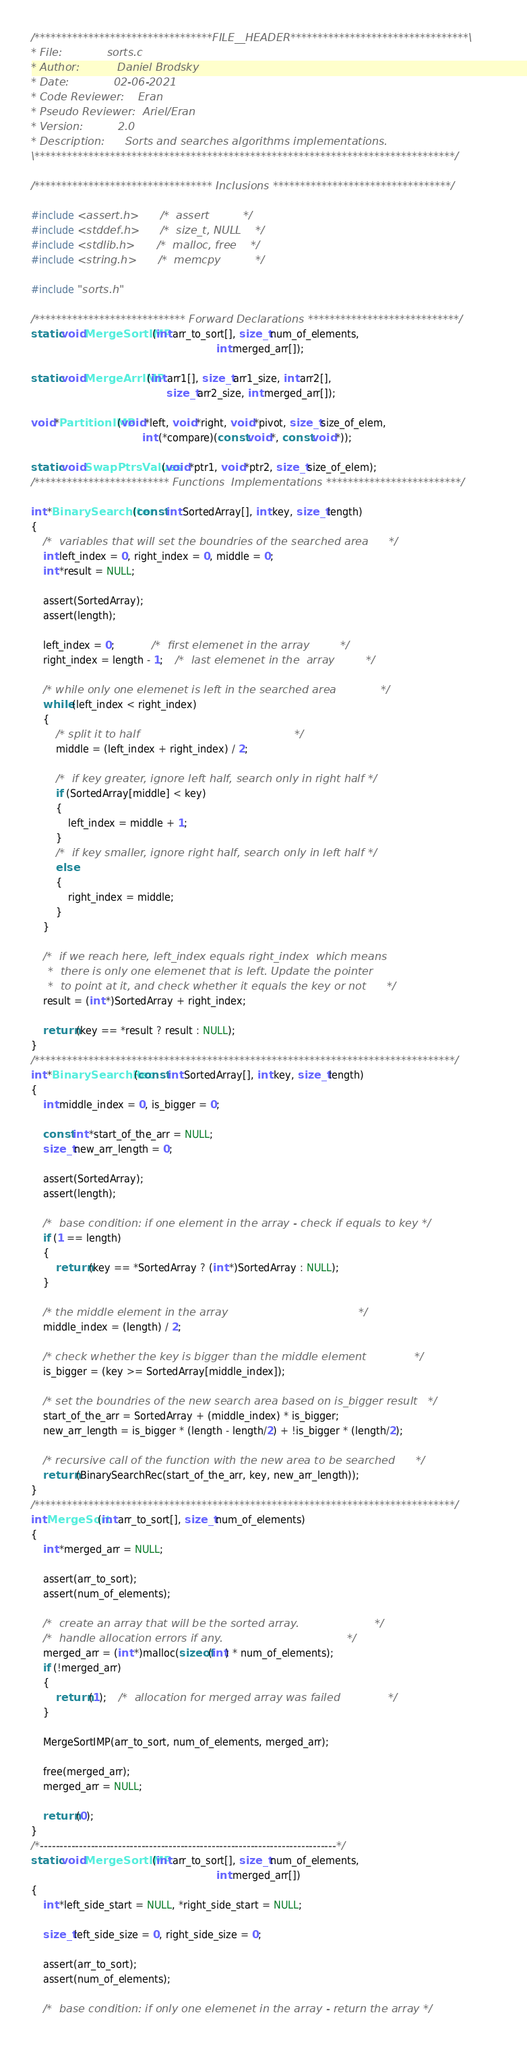Convert code to text. <code><loc_0><loc_0><loc_500><loc_500><_C_>/*********************************FILE__HEADER*********************************\
* File:				sorts.c
* Author:			Daniel Brodsky				 		  												  								
* Date:				02-06-2021
* Code Reviewer:	Eran
* Pseudo Reviewer: 	Ariel/Eran				   								
* Version:			2.0  								
* Description:		Sorts and searches algorithms implementations. 
\******************************************************************************/

/********************************* Inclusions *********************************/

#include <assert.h>		/*	assert			*/
#include <stddef.h>		/*	size_t, NULL	*/
#include <stdlib.h>		/*	malloc, free	*/
#include <string.h>		/*	memcpy			*/

#include "sorts.h"

/**************************** Forward Declarations ****************************/
static void MergeSortIMP(int arr_to_sort[], size_t num_of_elements,
															int merged_arr[]);

static void MergeArrIMP(int arr1[], size_t arr1_size, int arr2[], 
											size_t arr2_size, int merged_arr[]);

void *PartitionIMP(void *left, void *right, void *pivot, size_t size_of_elem, 
									int (*compare)(const void *, const void *));

static void SwapPtrsValues(void *ptr1, void *ptr2, size_t size_of_elem);
/************************* Functions  Implementations *************************/

int *BinarySearchIter(const int SortedArray[], int key, size_t length)
{
	/*	variables that will set the boundries of the searched area		*/
	int left_index = 0, right_index = 0, middle = 0;
	int *result = NULL;
	
	assert(SortedArray);
	assert(length);
	
	left_index = 0; 			/*	first elemenet in the array			*/
	right_index = length - 1;	/*	last elemenet in the  array			*/

	/* while only one elemenet is left in the searched area				*/
	while (left_index < right_index)
	{
		/* split it to half												*/
		middle = (left_index + right_index) / 2;
		
		/*	if key greater, ignore left half, search only in right half	*/
		if (SortedArray[middle] < key)
		{
			left_index = middle + 1;
		}
		/*	if key smaller, ignore right half, search only in left half	*/
		else
		{
			right_index = middle;
		}
	}

	/*	if we reach here, left_index equals right_index  which means
	 *	there is only one elemenet that is left. Update the pointer
	 *	to point at it, and check whether it equals the key or not		*/
	result = (int *)SortedArray + right_index;
			
	return (key == *result ? result : NULL);
}
/******************************************************************************/
int *BinarySearchRec(const int SortedArray[], int key, size_t length)
{
	int middle_index = 0, is_bigger = 0;
	
	const int *start_of_the_arr = NULL;
	size_t new_arr_length = 0;
	
	assert(SortedArray);
	assert(length);
		
	/*	base condition: if one element in the array - check if equals to key */
	if (1 == length)	
	{
		return (key == *SortedArray ? (int *)SortedArray : NULL);
	}
	
	/* the middle element in the array 										*/
	middle_index = (length) / 2;	

	/* check whether the key is bigger than the middle element				*/
	is_bigger = (key >= SortedArray[middle_index]);
	
	/* set the boundries of the new search area based on is_bigger result 	*/
	start_of_the_arr = SortedArray + (middle_index) * is_bigger;
	new_arr_length = is_bigger * (length - length/2) + !is_bigger * (length/2);
	
	/* recursive call of the function with the new area to be searched 		*/ 
	return (BinarySearchRec(start_of_the_arr, key, new_arr_length));
}
/******************************************************************************/
int MergeSort(int arr_to_sort[], size_t num_of_elements)
{
	int *merged_arr = NULL;
	
	assert(arr_to_sort);
	assert(num_of_elements);
	
	/*	create an array that will be the sorted array.						*/
	/*	handle allocation errors if any.									*/
	merged_arr = (int *)malloc(sizeof(int) * num_of_elements);
	if (!merged_arr)
	{
		return (1);	/*	allocation for merged array was failed				*/
	}
	
	MergeSortIMP(arr_to_sort, num_of_elements, merged_arr);
	
	free(merged_arr);
	merged_arr = NULL;
	
	return (0);
}
/*----------------------------------------------------------------------------*/
static void MergeSortIMP(int arr_to_sort[], size_t num_of_elements,
															int merged_arr[])
{	
	int *left_side_start = NULL, *right_side_start = NULL;
	
	size_t left_side_size = 0, right_side_size = 0;

	assert(arr_to_sort);
	assert(num_of_elements);
	
	/*	base condition:	if only one elemenet in the array - return the array */</code> 